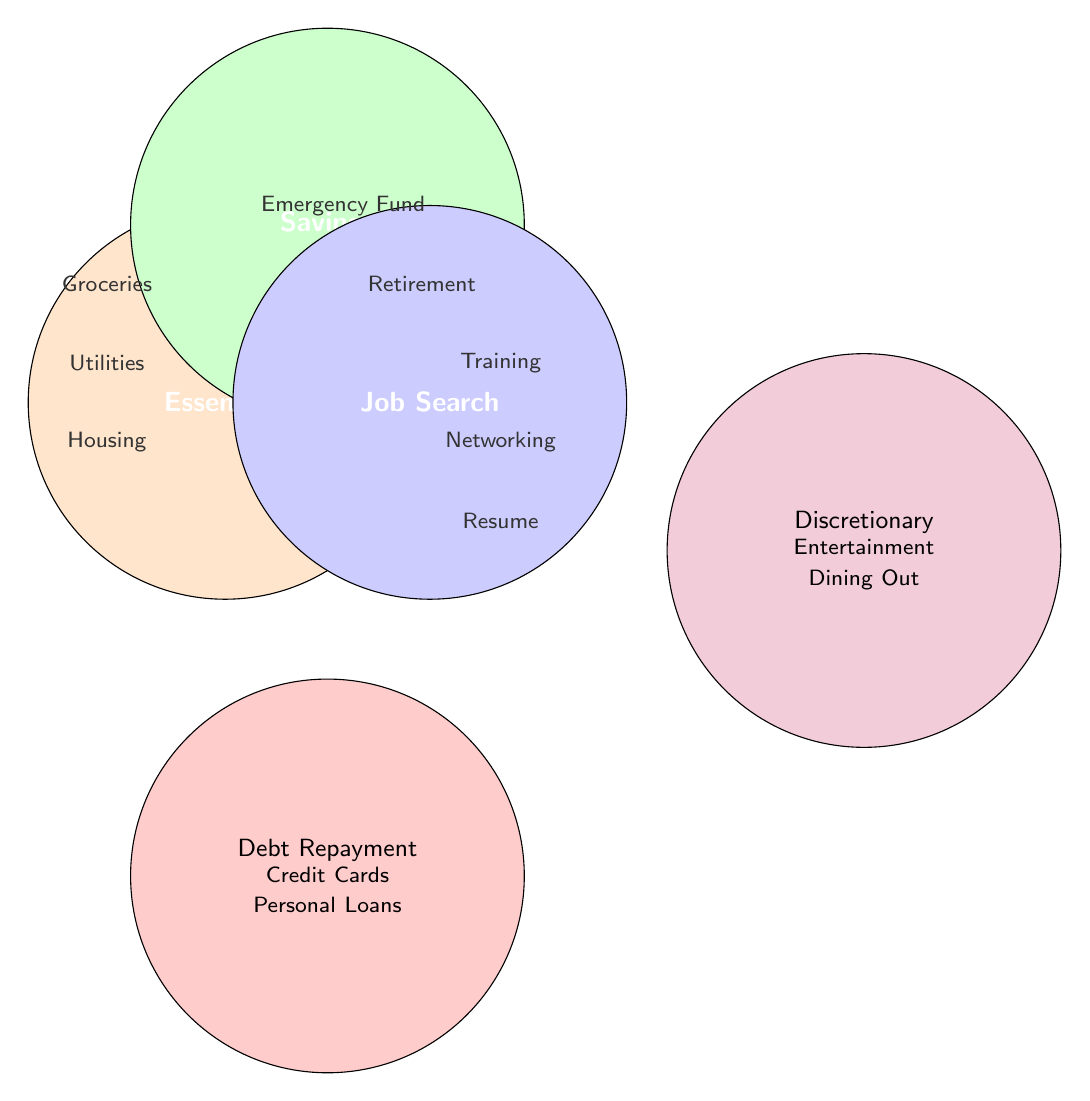What categories are included in the Venn Diagram? The Venn Diagram consists of three main categories: Essentials, Savings, and Job Search. Additionally, there are two separate boxes for Debt Repayment and Discretionary.
Answer: Essentials, Savings, Job Search, Debt Repayment, Discretionary Which category contains Groceries? By looking at the Venn Diagram, Groceries is in the section labeled Essentials.
Answer: Essentials How many subcategories are listed under the Essentials category? The Essentials category includes three subcategories: Housing, Utilities, and Groceries.
Answer: 3 Which subcategory falls under Debt Repayment? The two subcategories listed under Debt Repayment are Credit Cards and Personal Loans.
Answer: Credit Cards, Personal Loans Which category has the most subcategories? The Job Search category has three subcategories: Networking Events, Skills Training, and Resume Services.
Answer: Job Search Which categories do not overlap with any other categories? The two separate boxes labeled Debt Repayment and Discretionary do not overlap with any other categories.
Answer: Debt Repayment, Discretionary What is the shared color between Essentials, Savings, and Job Search? The overlapping area between Essentials, Savings, and Job Search is colored orange, green, and blue for their respective sections.
Answer: There is no shared color among all three categories Which categories could logically intersect with each other? Based on common budgeting practices, Essentials and Savings could intersect as some essentials may have savings aspects (e.g., budgeting for groceries); Savings and Job Search could intersect as saving for job-related expenses (e.g., training).
Answer: Essentials and Savings, Savings and Job Search 